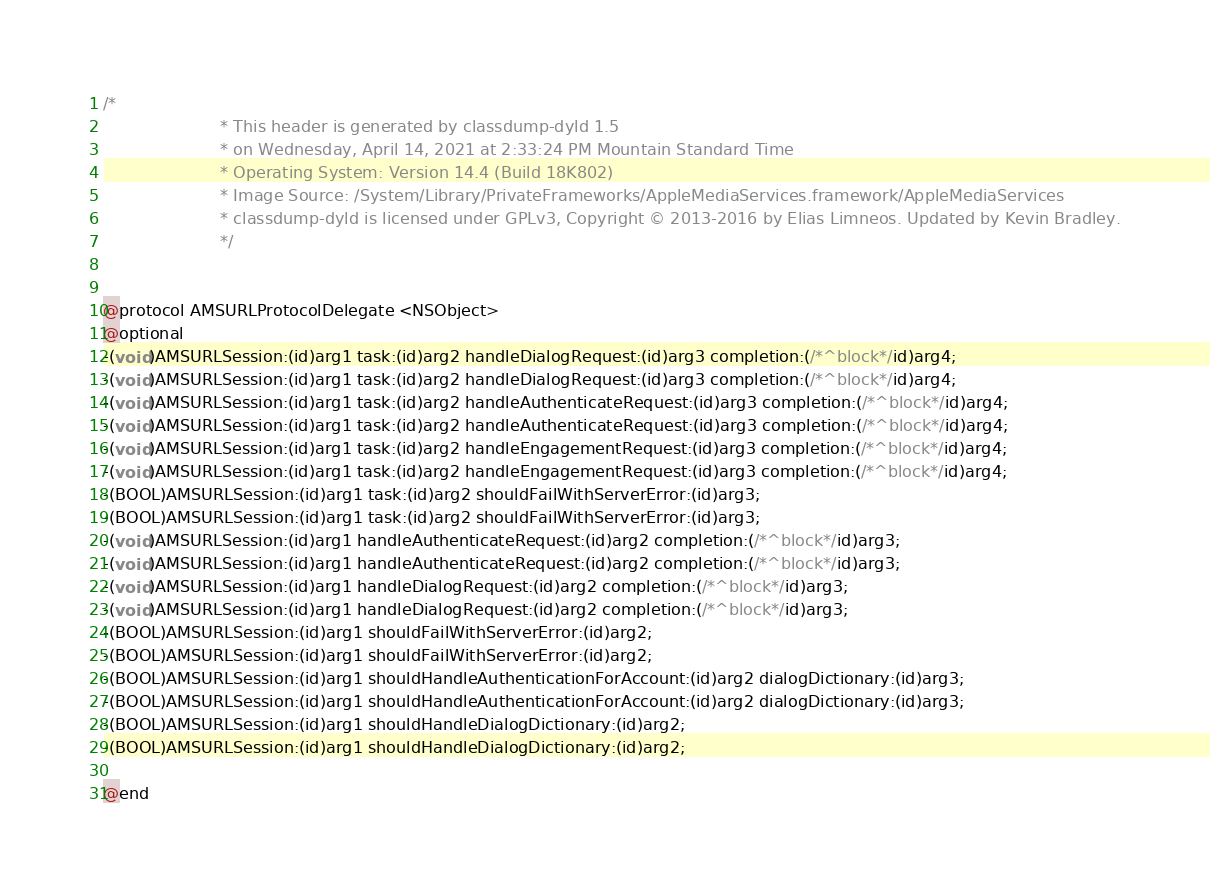Convert code to text. <code><loc_0><loc_0><loc_500><loc_500><_C_>/*
                       * This header is generated by classdump-dyld 1.5
                       * on Wednesday, April 14, 2021 at 2:33:24 PM Mountain Standard Time
                       * Operating System: Version 14.4 (Build 18K802)
                       * Image Source: /System/Library/PrivateFrameworks/AppleMediaServices.framework/AppleMediaServices
                       * classdump-dyld is licensed under GPLv3, Copyright © 2013-2016 by Elias Limneos. Updated by Kevin Bradley.
                       */


@protocol AMSURLProtocolDelegate <NSObject>
@optional
-(void)AMSURLSession:(id)arg1 task:(id)arg2 handleDialogRequest:(id)arg3 completion:(/*^block*/id)arg4;
-(void)AMSURLSession:(id)arg1 task:(id)arg2 handleDialogRequest:(id)arg3 completion:(/*^block*/id)arg4;
-(void)AMSURLSession:(id)arg1 task:(id)arg2 handleAuthenticateRequest:(id)arg3 completion:(/*^block*/id)arg4;
-(void)AMSURLSession:(id)arg1 task:(id)arg2 handleAuthenticateRequest:(id)arg3 completion:(/*^block*/id)arg4;
-(void)AMSURLSession:(id)arg1 task:(id)arg2 handleEngagementRequest:(id)arg3 completion:(/*^block*/id)arg4;
-(void)AMSURLSession:(id)arg1 task:(id)arg2 handleEngagementRequest:(id)arg3 completion:(/*^block*/id)arg4;
-(BOOL)AMSURLSession:(id)arg1 task:(id)arg2 shouldFailWithServerError:(id)arg3;
-(BOOL)AMSURLSession:(id)arg1 task:(id)arg2 shouldFailWithServerError:(id)arg3;
-(void)AMSURLSession:(id)arg1 handleAuthenticateRequest:(id)arg2 completion:(/*^block*/id)arg3;
-(void)AMSURLSession:(id)arg1 handleAuthenticateRequest:(id)arg2 completion:(/*^block*/id)arg3;
-(void)AMSURLSession:(id)arg1 handleDialogRequest:(id)arg2 completion:(/*^block*/id)arg3;
-(void)AMSURLSession:(id)arg1 handleDialogRequest:(id)arg2 completion:(/*^block*/id)arg3;
-(BOOL)AMSURLSession:(id)arg1 shouldFailWithServerError:(id)arg2;
-(BOOL)AMSURLSession:(id)arg1 shouldFailWithServerError:(id)arg2;
-(BOOL)AMSURLSession:(id)arg1 shouldHandleAuthenticationForAccount:(id)arg2 dialogDictionary:(id)arg3;
-(BOOL)AMSURLSession:(id)arg1 shouldHandleAuthenticationForAccount:(id)arg2 dialogDictionary:(id)arg3;
-(BOOL)AMSURLSession:(id)arg1 shouldHandleDialogDictionary:(id)arg2;
-(BOOL)AMSURLSession:(id)arg1 shouldHandleDialogDictionary:(id)arg2;

@end

</code> 